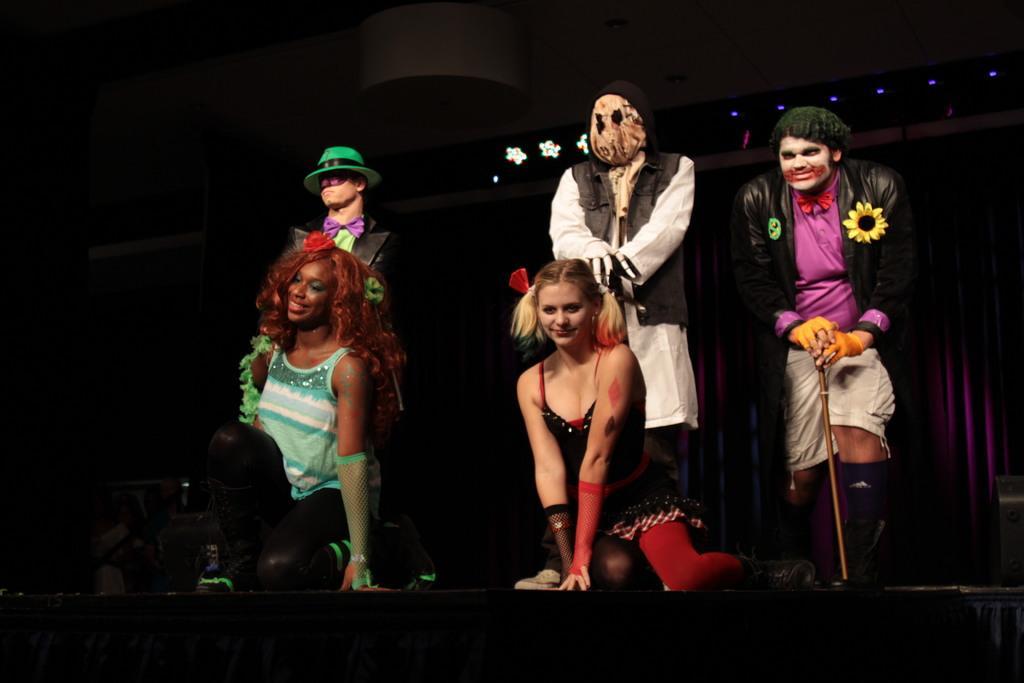How would you summarize this image in a sentence or two? In this image we can see two women smiling and three men standing and these five people are performing on the stage. In the background we can see the curtain. We can also see the lights to the ceiling. 